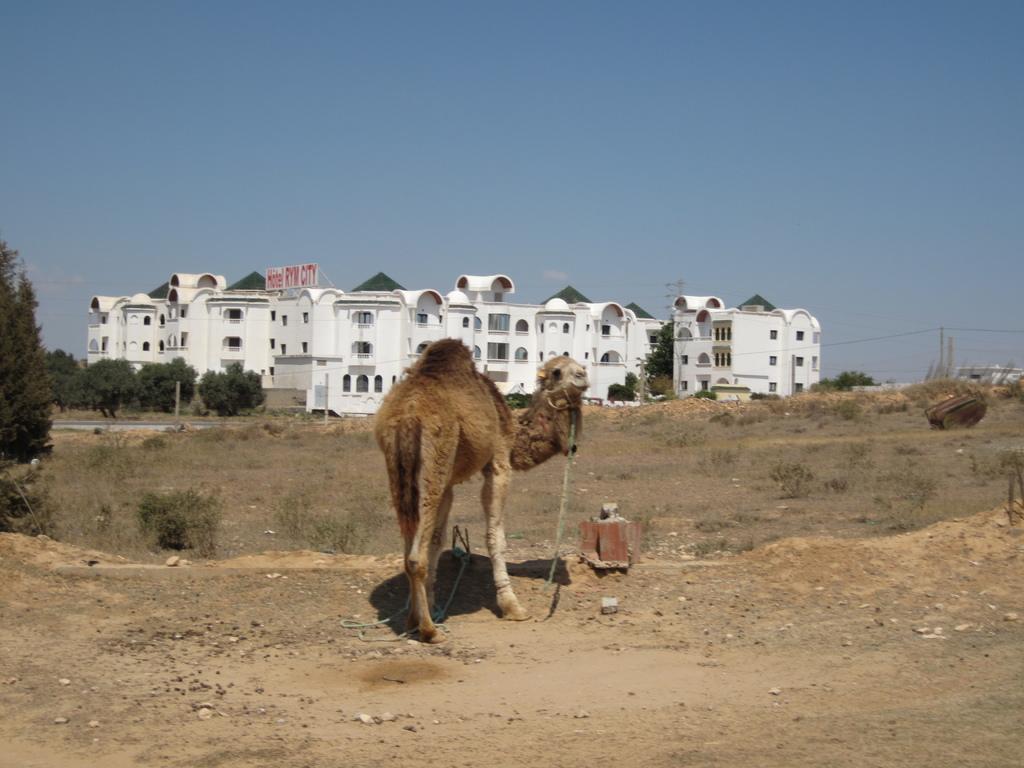Can you describe this image briefly? In this image there is a camel on a land, in the background there are trees, buildings and the sky. 